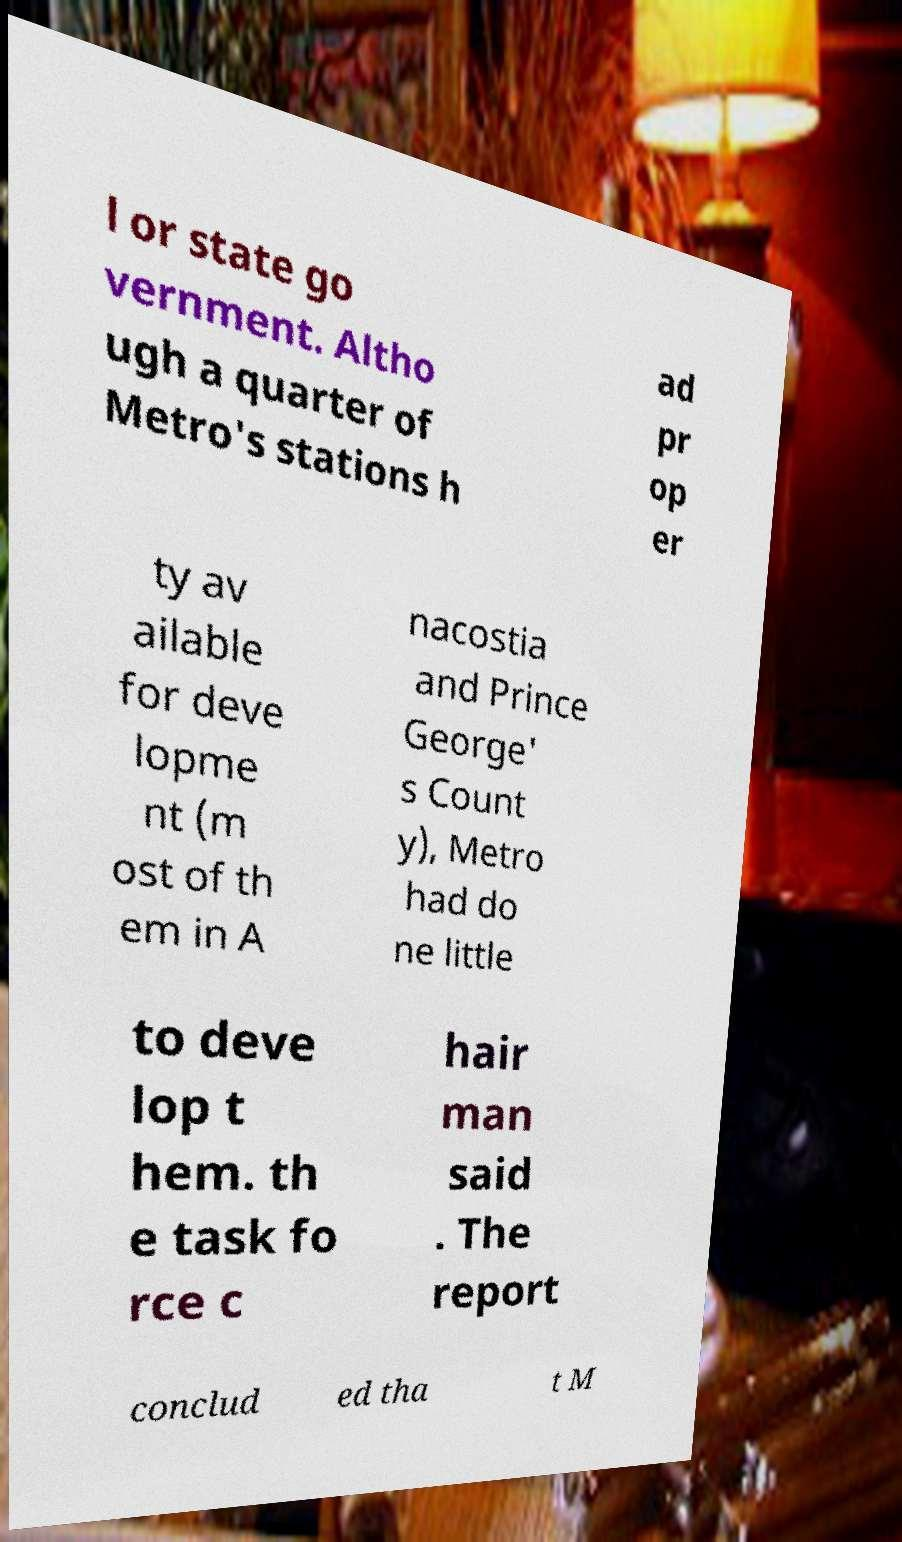Please identify and transcribe the text found in this image. l or state go vernment. Altho ugh a quarter of Metro's stations h ad pr op er ty av ailable for deve lopme nt (m ost of th em in A nacostia and Prince George' s Count y), Metro had do ne little to deve lop t hem. th e task fo rce c hair man said . The report conclud ed tha t M 